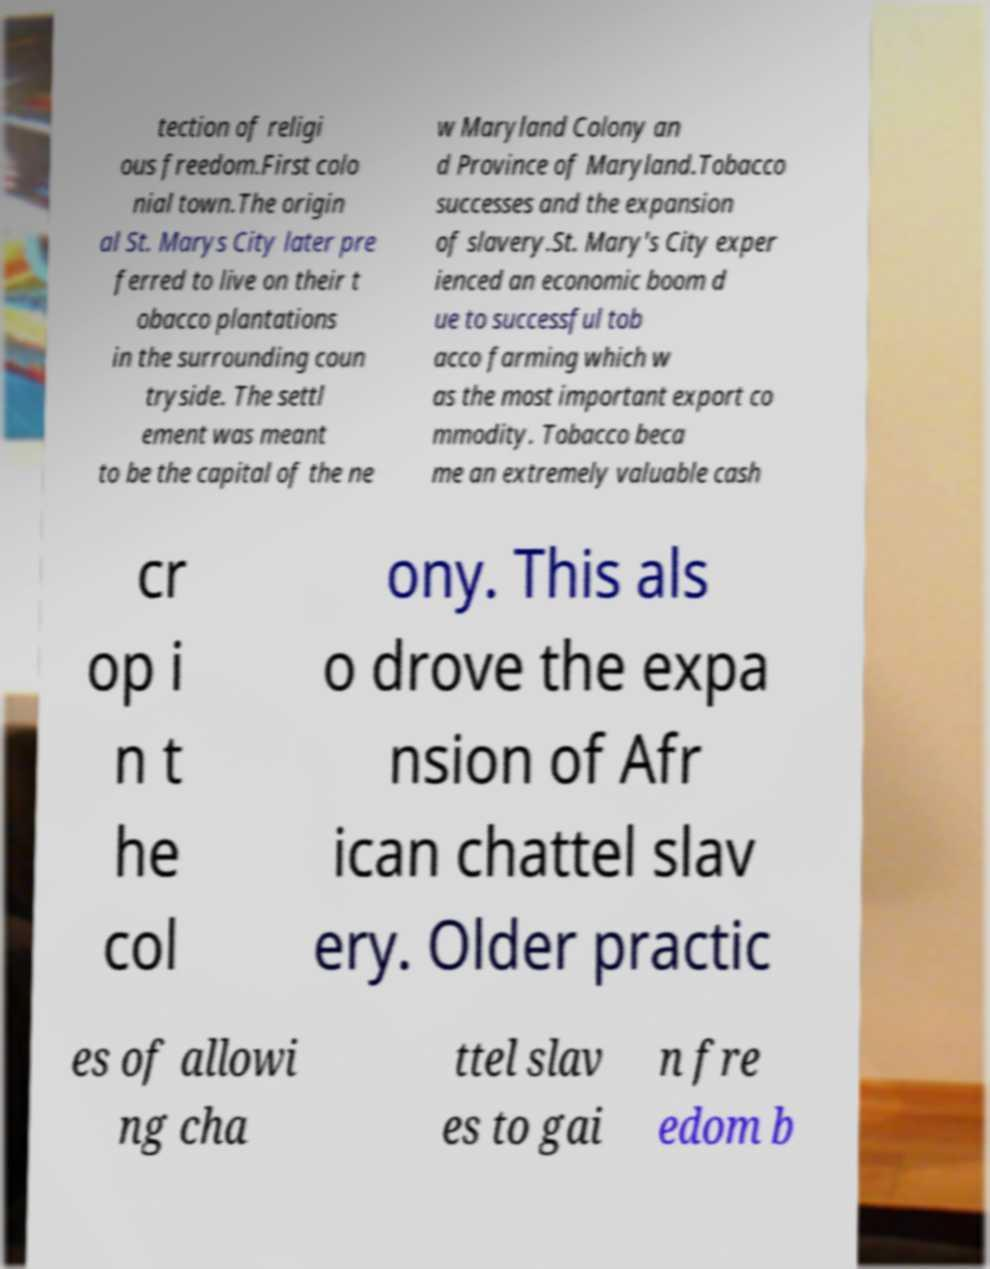What messages or text are displayed in this image? I need them in a readable, typed format. tection of religi ous freedom.First colo nial town.The origin al St. Marys City later pre ferred to live on their t obacco plantations in the surrounding coun tryside. The settl ement was meant to be the capital of the ne w Maryland Colony an d Province of Maryland.Tobacco successes and the expansion of slavery.St. Mary's City exper ienced an economic boom d ue to successful tob acco farming which w as the most important export co mmodity. Tobacco beca me an extremely valuable cash cr op i n t he col ony. This als o drove the expa nsion of Afr ican chattel slav ery. Older practic es of allowi ng cha ttel slav es to gai n fre edom b 